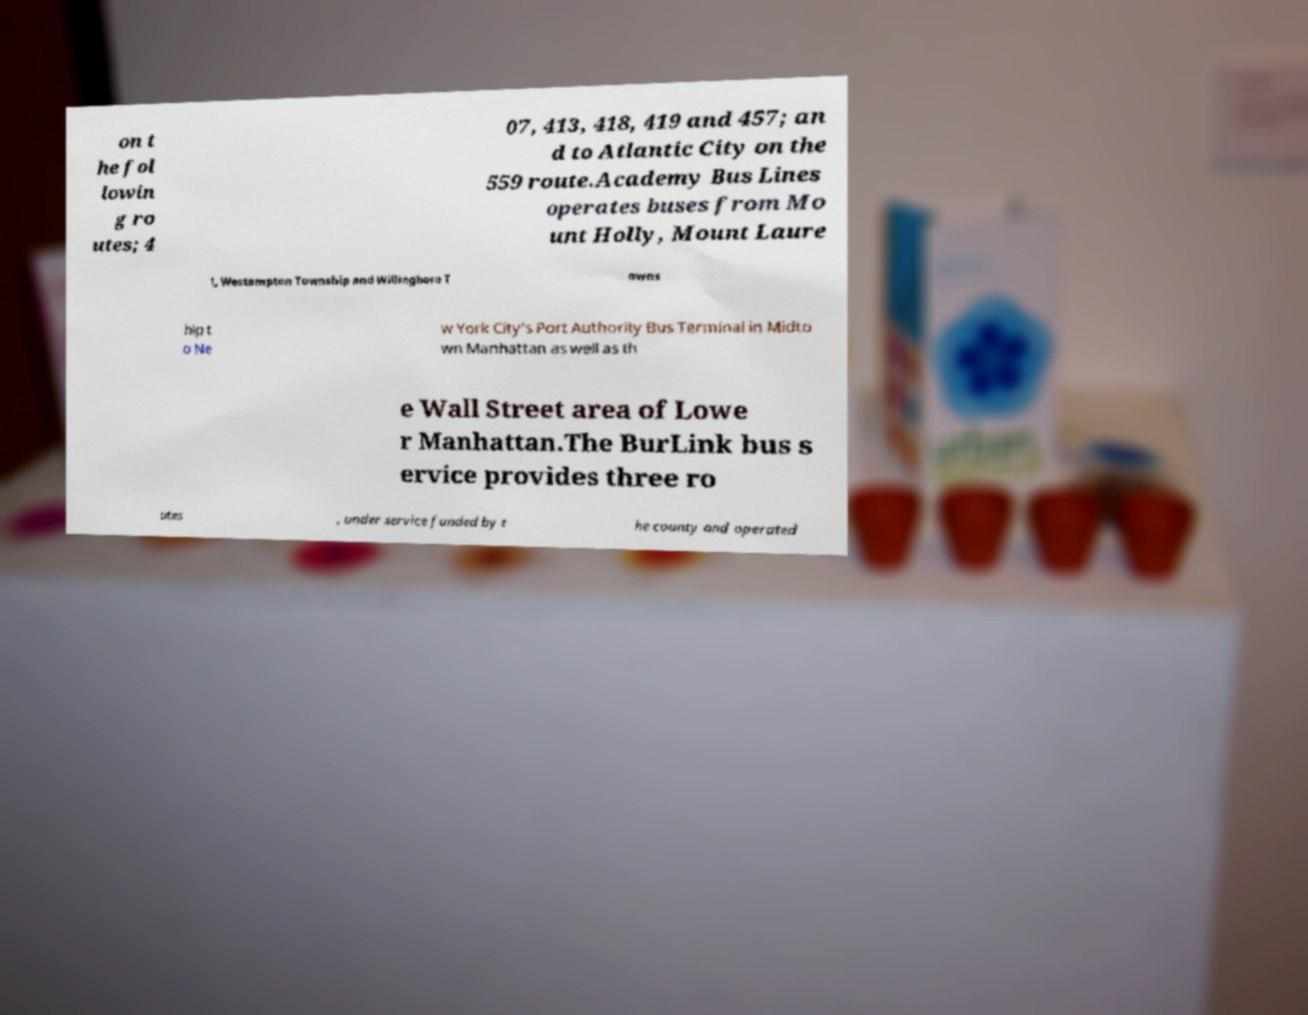I need the written content from this picture converted into text. Can you do that? on t he fol lowin g ro utes; 4 07, 413, 418, 419 and 457; an d to Atlantic City on the 559 route.Academy Bus Lines operates buses from Mo unt Holly, Mount Laure l, Westampton Township and Willingboro T owns hip t o Ne w York City's Port Authority Bus Terminal in Midto wn Manhattan as well as th e Wall Street area of Lowe r Manhattan.The BurLink bus s ervice provides three ro utes , under service funded by t he county and operated 